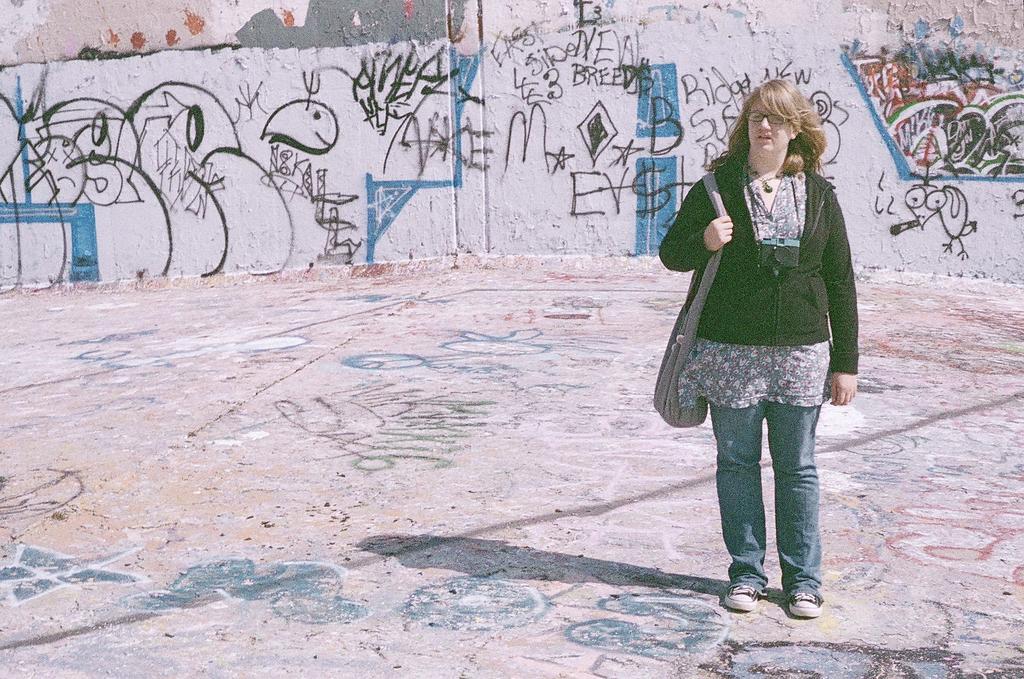Could you give a brief overview of what you see in this image? In this image on the right side there is one woman standing and she is wearing bag, and in the background there is wall on the wall there is some art. At the bottom there is walkway and on the walkway there is some art. 